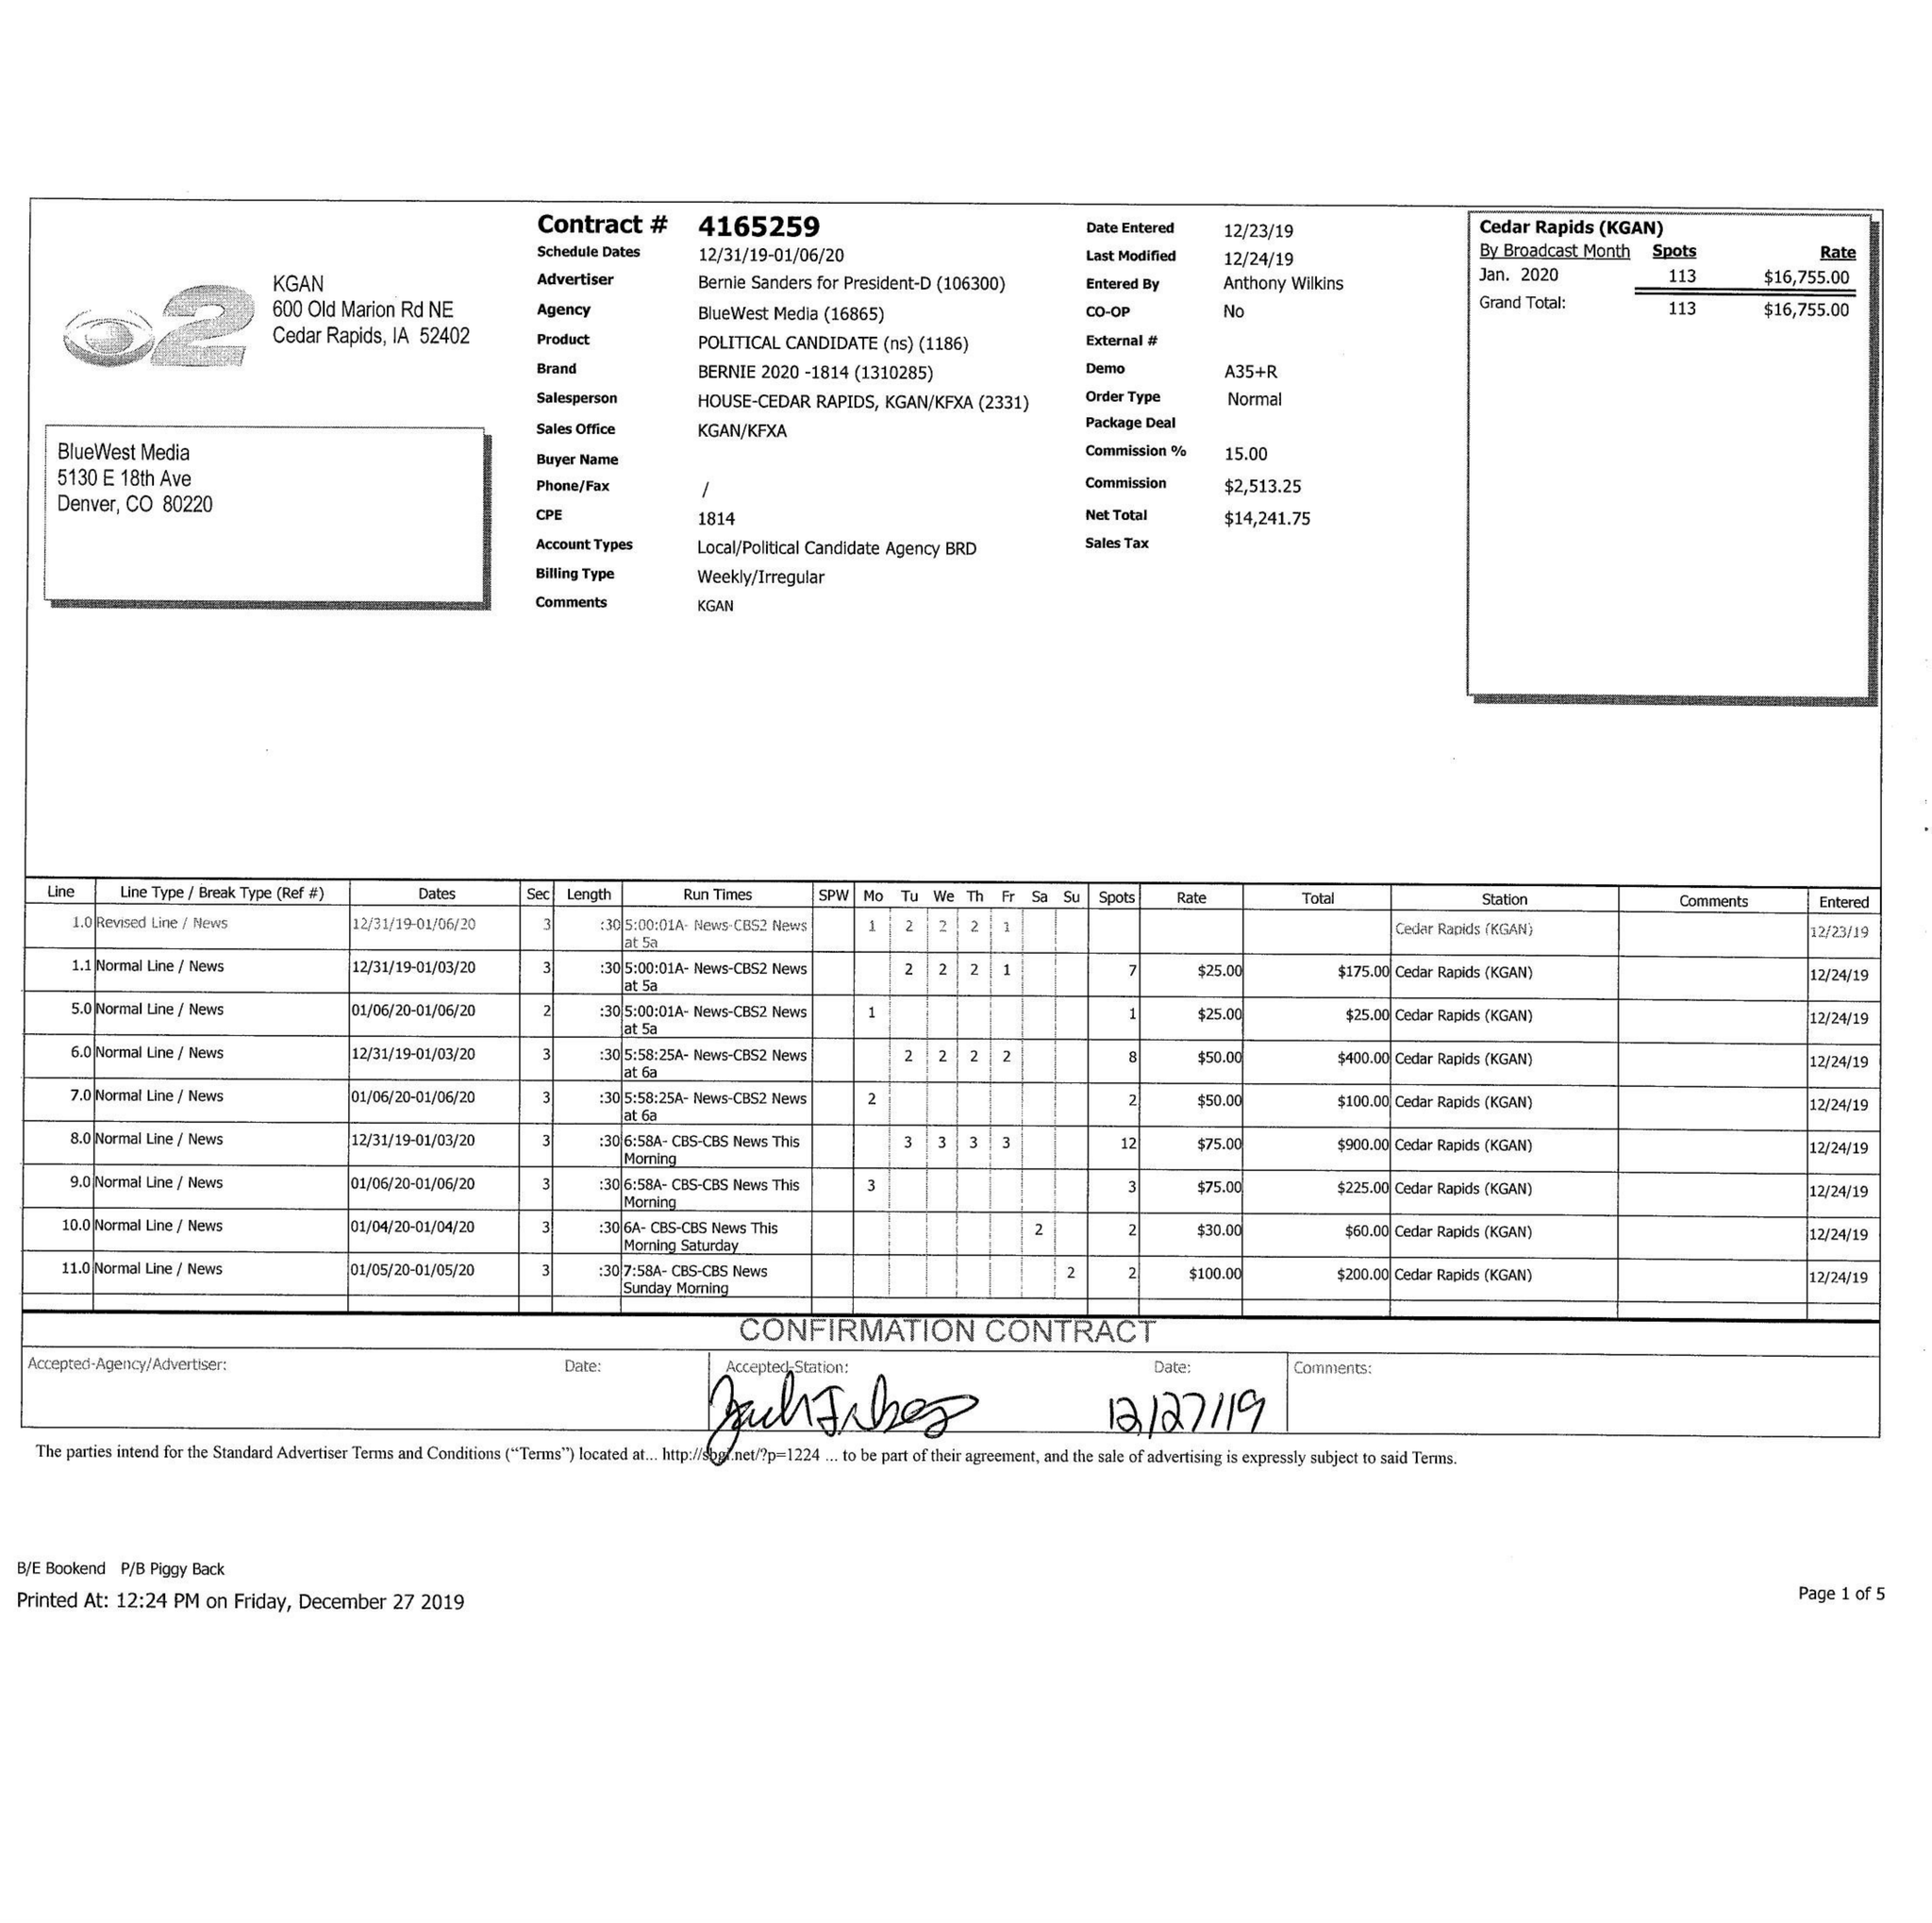What is the value for the contract_num?
Answer the question using a single word or phrase. 4165259 